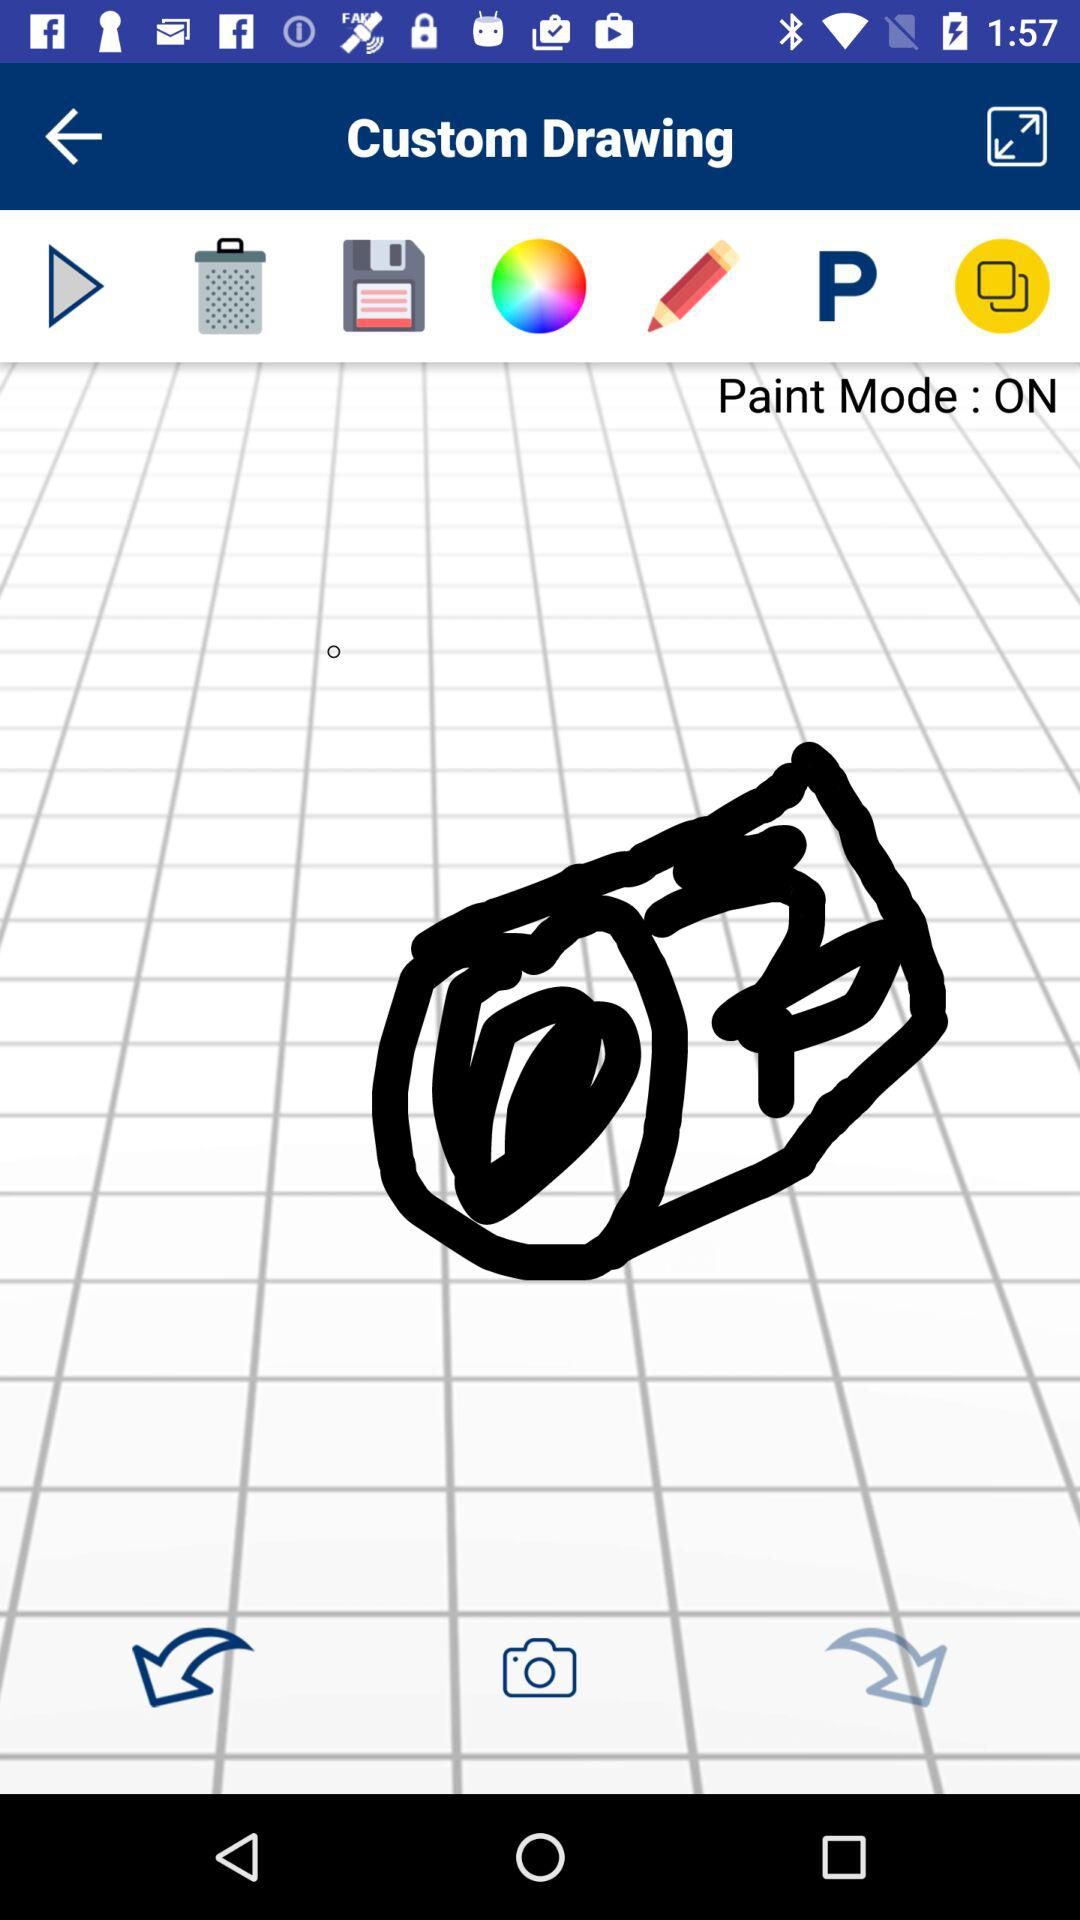What is the status of paint mode? The status is on. 